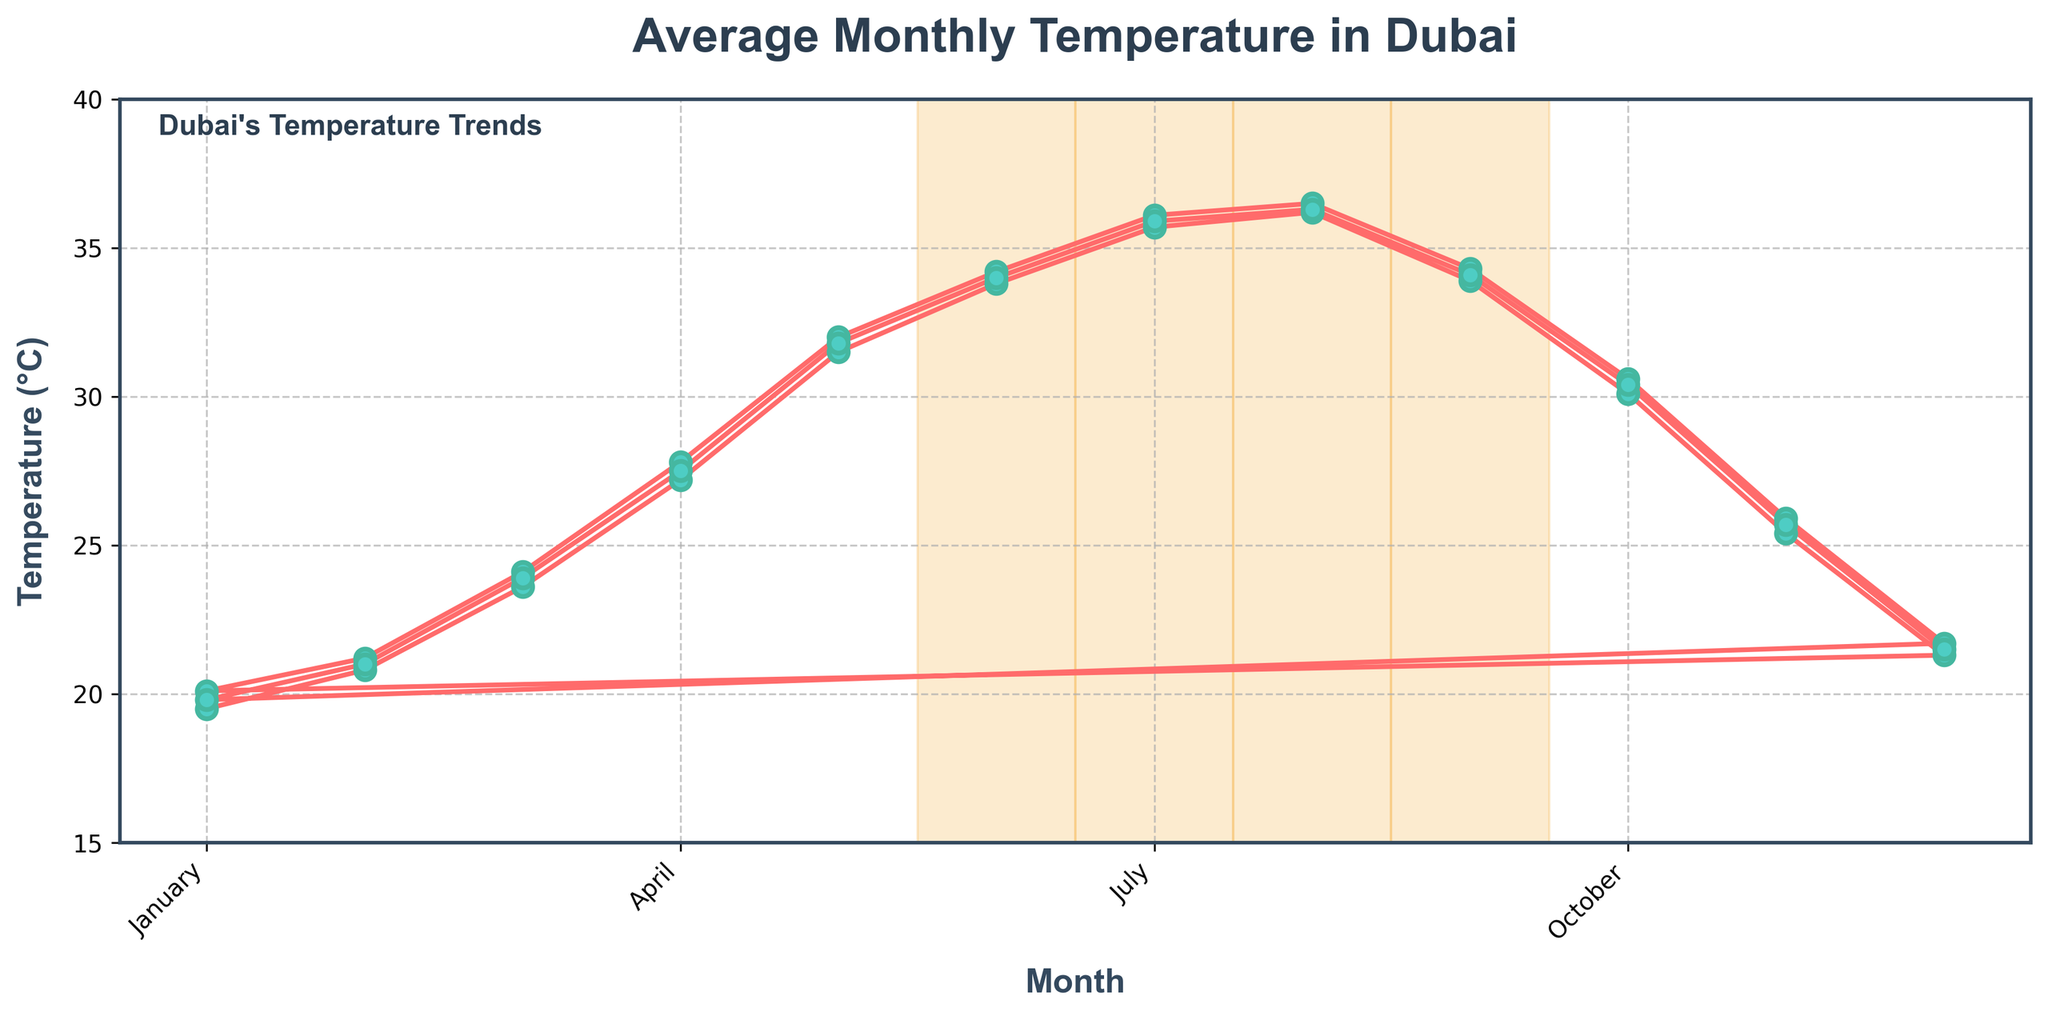What is the warmest month in Dubai according to the figure? The warmest month can be identified by finding the highest peak on the line chart, which is August.
Answer: August Which month has a lower average temperature, March or September? Compare the data points for March and September on the line chart: March has a lower temperature because its point is visibly lower than September's.
Answer: March What is the average temperature in January over the past 10 years? Notice the data points for January across the years, calculate the average: (19.5 + 20.1 + 19.8) / 3 = 19.8
Answer: 19.8°C How does the temperature in November compare to that in May? Comparing the heights of the data points for November and May: November (25.4 - 25.9) is lower than May (31.5 - 32.0).
Answer: November is cooler Is there any month where the temperature exceeds 35°C? If so, which one? Look at the line chart for points surpassing the 35°C mark, which occur in July and August.
Answer: Yes, July and August What can you infer about the temperature trend from June to September? Examine the segment from June to September: temperatures rise from June (average around 34°C) to August (36.2°C - 36.5°C), then slightly fall in September (33.9°C - 34.3°C).
Answer: Temperatures peak in August and start to decline in September How does the summer period (highlighted in yellow) generally differ from the rest of the year? Compare the temperatures in the highlighted summer months (May-August) with the other months: summer months show consistently higher temperatures.
Answer: Summer is hotter overall What is the average increase in temperature from January to July? Calculate the difference between July and January for each year and average them: ((35.7 - 19.5) + (36.1 - 20.1) + (35.9 - 19.8))/3 ≈ 16.4°C
Answer: 16.4°C Considering the graph, during which season do you expect the mildest weather in Dubai? Mild weather is indicated by the lowest points on the graph, which occur in January - March (winter-spring).
Answer: Winter-Spring 